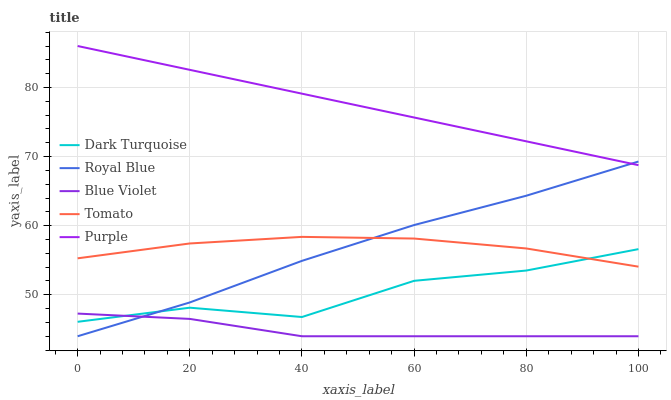Does Blue Violet have the minimum area under the curve?
Answer yes or no. Yes. Does Purple have the maximum area under the curve?
Answer yes or no. Yes. Does Dark Turquoise have the minimum area under the curve?
Answer yes or no. No. Does Dark Turquoise have the maximum area under the curve?
Answer yes or no. No. Is Purple the smoothest?
Answer yes or no. Yes. Is Dark Turquoise the roughest?
Answer yes or no. Yes. Is Dark Turquoise the smoothest?
Answer yes or no. No. Is Purple the roughest?
Answer yes or no. No. Does Blue Violet have the lowest value?
Answer yes or no. Yes. Does Dark Turquoise have the lowest value?
Answer yes or no. No. Does Purple have the highest value?
Answer yes or no. Yes. Does Dark Turquoise have the highest value?
Answer yes or no. No. Is Tomato less than Purple?
Answer yes or no. Yes. Is Tomato greater than Blue Violet?
Answer yes or no. Yes. Does Royal Blue intersect Tomato?
Answer yes or no. Yes. Is Royal Blue less than Tomato?
Answer yes or no. No. Is Royal Blue greater than Tomato?
Answer yes or no. No. Does Tomato intersect Purple?
Answer yes or no. No. 